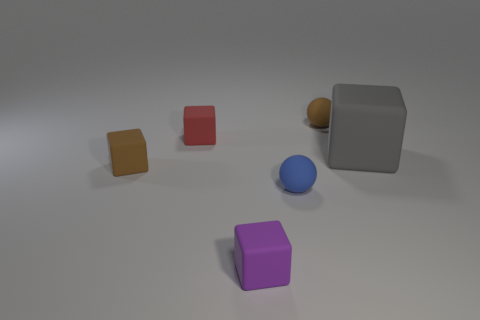Subtract all small cubes. How many cubes are left? 1 Subtract all gray cubes. How many cubes are left? 3 Subtract all blue blocks. Subtract all yellow spheres. How many blocks are left? 4 Add 3 brown cylinders. How many objects exist? 9 Subtract all blocks. How many objects are left? 2 Subtract 0 cyan spheres. How many objects are left? 6 Subtract all brown rubber cubes. Subtract all brown rubber balls. How many objects are left? 4 Add 2 tiny rubber balls. How many tiny rubber balls are left? 4 Add 5 small brown things. How many small brown things exist? 7 